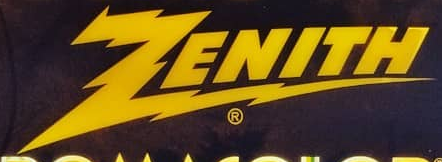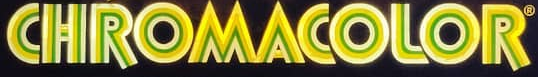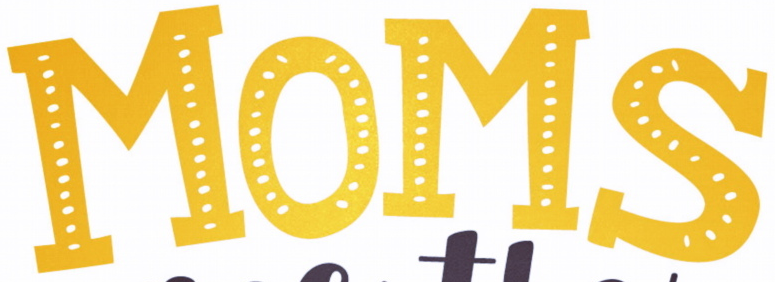Identify the words shown in these images in order, separated by a semicolon. ZENITH; CHROMACOLOR; MOMS 